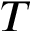Convert formula to latex. <formula><loc_0><loc_0><loc_500><loc_500>T</formula> 